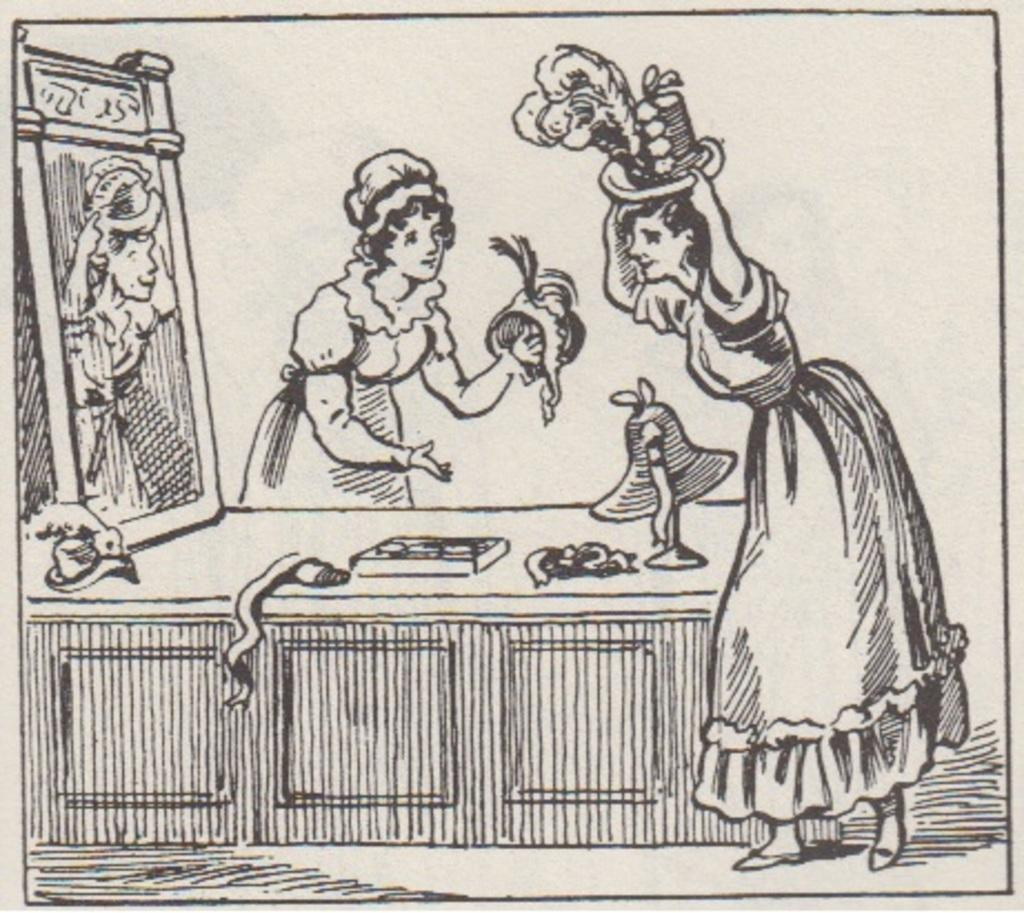What is depicted on the paper in the image? There is a drawing on a paper in the image. What type of acoustics can be heard from the crate in the image? There is no crate present in the image, and therefore no acoustics can be heard. 